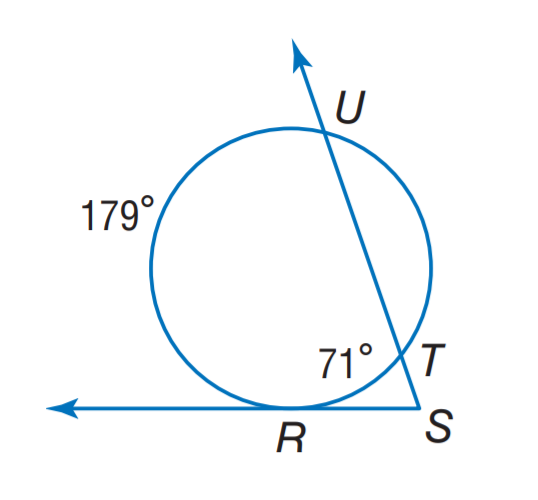Answer the mathemtical geometry problem and directly provide the correct option letter.
Question: Find m \angle S.
Choices: A: 27 B: 35.5 C: 54 D: 71 C 